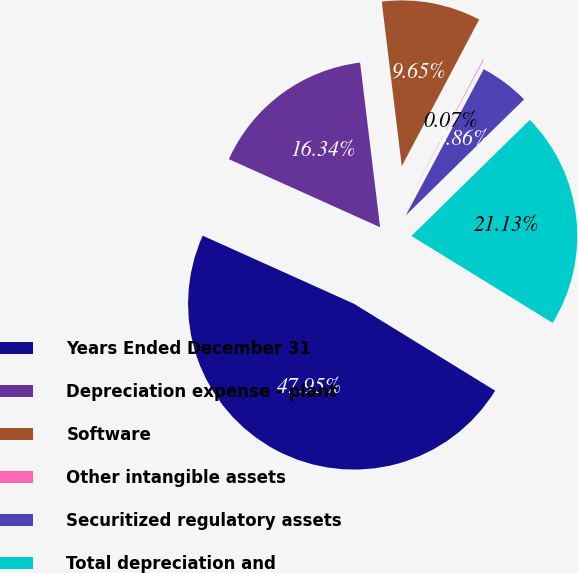<chart> <loc_0><loc_0><loc_500><loc_500><pie_chart><fcel>Years Ended December 31<fcel>Depreciation expense - plant<fcel>Software<fcel>Other intangible assets<fcel>Securitized regulatory assets<fcel>Total depreciation and<nl><fcel>47.95%<fcel>16.34%<fcel>9.65%<fcel>0.07%<fcel>4.86%<fcel>21.13%<nl></chart> 